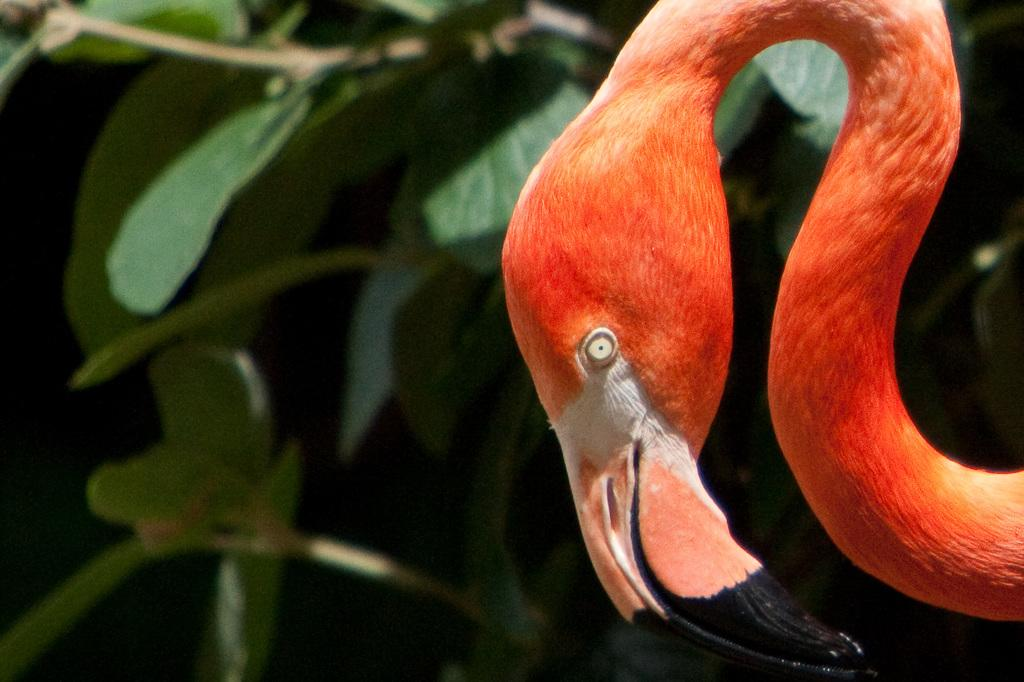What type of animal can be seen in the image? There is an animal with an orange color in the image. What is a distinctive feature of the animal? The animal has a long beak. What can be seen in the background of the image? There is a group of plants in the background of the image. How does the sponge interact with the animal in the image? There is no sponge present in the image, so it cannot interact with the animal. 